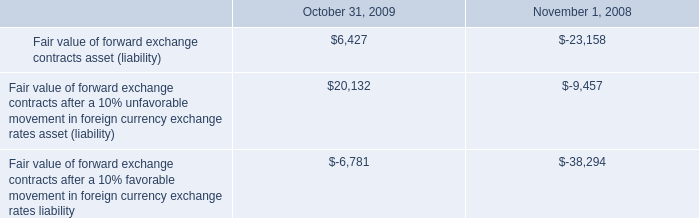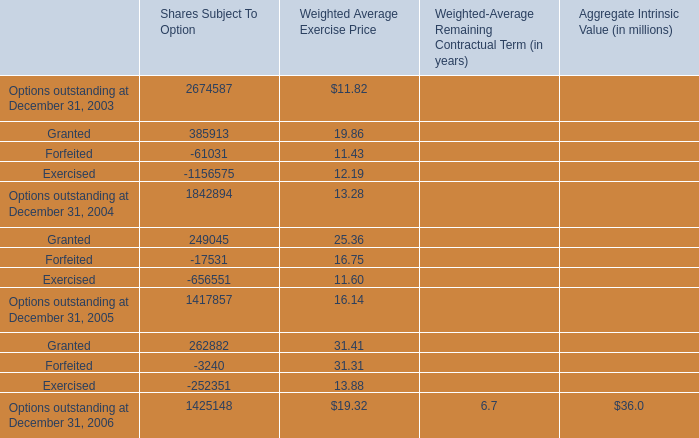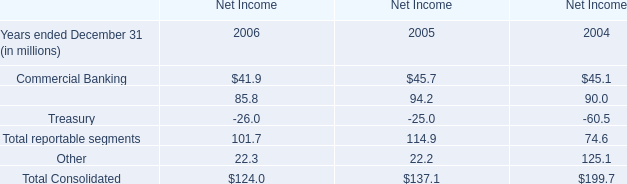In the year with the most Forfeited for Shares Subject To Option, what is the growth rate of Granted for Shares Subject To Option? 
Computations: ((262882 - 249045) / 249045)
Answer: 0.05556. 